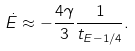Convert formula to latex. <formula><loc_0><loc_0><loc_500><loc_500>\dot { E } \approx - \frac { 4 \gamma } { 3 } \frac { 1 } { t _ { E - 1 / 4 } } .</formula> 